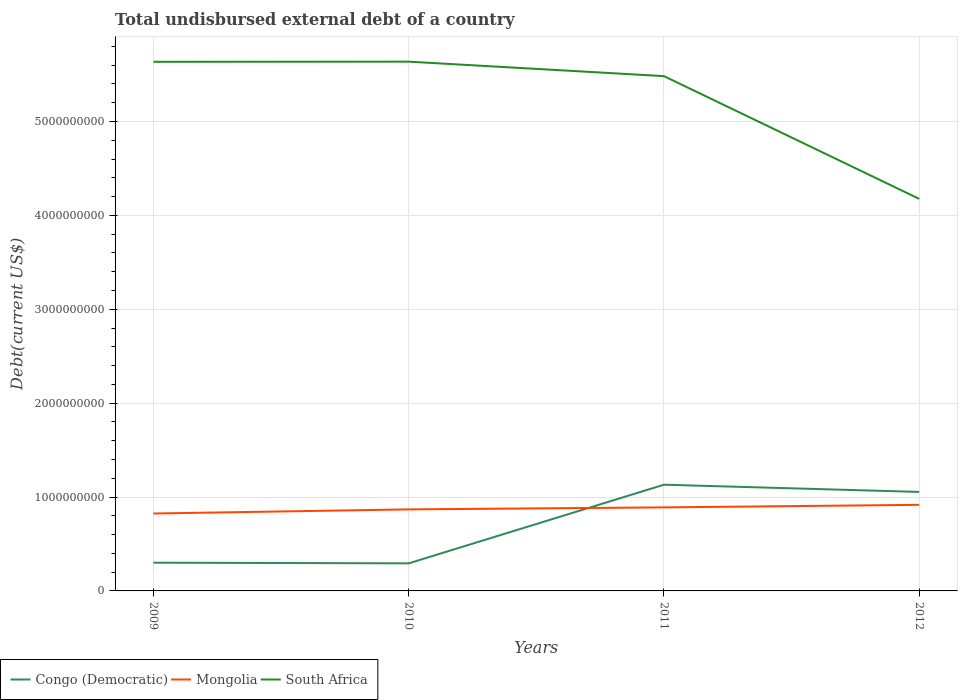How many different coloured lines are there?
Offer a terse response. 3. Across all years, what is the maximum total undisbursed external debt in Mongolia?
Provide a succinct answer. 8.24e+08. In which year was the total undisbursed external debt in South Africa maximum?
Give a very brief answer. 2012. What is the total total undisbursed external debt in South Africa in the graph?
Provide a short and direct response. -1.40e+06. What is the difference between the highest and the second highest total undisbursed external debt in South Africa?
Provide a short and direct response. 1.46e+09. What is the difference between the highest and the lowest total undisbursed external debt in Mongolia?
Give a very brief answer. 2. What is the difference between two consecutive major ticks on the Y-axis?
Make the answer very short. 1.00e+09. Are the values on the major ticks of Y-axis written in scientific E-notation?
Make the answer very short. No. Does the graph contain any zero values?
Your response must be concise. No. Where does the legend appear in the graph?
Ensure brevity in your answer.  Bottom left. How many legend labels are there?
Provide a succinct answer. 3. How are the legend labels stacked?
Offer a terse response. Horizontal. What is the title of the graph?
Offer a very short reply. Total undisbursed external debt of a country. Does "Antigua and Barbuda" appear as one of the legend labels in the graph?
Provide a succinct answer. No. What is the label or title of the Y-axis?
Ensure brevity in your answer.  Debt(current US$). What is the Debt(current US$) of Congo (Democratic) in 2009?
Keep it short and to the point. 3.01e+08. What is the Debt(current US$) in Mongolia in 2009?
Give a very brief answer. 8.24e+08. What is the Debt(current US$) in South Africa in 2009?
Your response must be concise. 5.64e+09. What is the Debt(current US$) of Congo (Democratic) in 2010?
Keep it short and to the point. 2.94e+08. What is the Debt(current US$) of Mongolia in 2010?
Give a very brief answer. 8.69e+08. What is the Debt(current US$) in South Africa in 2010?
Provide a succinct answer. 5.64e+09. What is the Debt(current US$) of Congo (Democratic) in 2011?
Your answer should be compact. 1.13e+09. What is the Debt(current US$) of Mongolia in 2011?
Make the answer very short. 8.90e+08. What is the Debt(current US$) of South Africa in 2011?
Your response must be concise. 5.48e+09. What is the Debt(current US$) in Congo (Democratic) in 2012?
Offer a terse response. 1.05e+09. What is the Debt(current US$) of Mongolia in 2012?
Offer a terse response. 9.17e+08. What is the Debt(current US$) in South Africa in 2012?
Offer a terse response. 4.18e+09. Across all years, what is the maximum Debt(current US$) of Congo (Democratic)?
Keep it short and to the point. 1.13e+09. Across all years, what is the maximum Debt(current US$) in Mongolia?
Make the answer very short. 9.17e+08. Across all years, what is the maximum Debt(current US$) in South Africa?
Provide a succinct answer. 5.64e+09. Across all years, what is the minimum Debt(current US$) in Congo (Democratic)?
Your answer should be compact. 2.94e+08. Across all years, what is the minimum Debt(current US$) of Mongolia?
Your answer should be compact. 8.24e+08. Across all years, what is the minimum Debt(current US$) in South Africa?
Offer a terse response. 4.18e+09. What is the total Debt(current US$) in Congo (Democratic) in the graph?
Provide a succinct answer. 2.78e+09. What is the total Debt(current US$) in Mongolia in the graph?
Your response must be concise. 3.50e+09. What is the total Debt(current US$) of South Africa in the graph?
Offer a very short reply. 2.09e+1. What is the difference between the Debt(current US$) of Congo (Democratic) in 2009 and that in 2010?
Provide a succinct answer. 7.04e+06. What is the difference between the Debt(current US$) of Mongolia in 2009 and that in 2010?
Provide a short and direct response. -4.41e+07. What is the difference between the Debt(current US$) in South Africa in 2009 and that in 2010?
Provide a short and direct response. -1.40e+06. What is the difference between the Debt(current US$) of Congo (Democratic) in 2009 and that in 2011?
Make the answer very short. -8.31e+08. What is the difference between the Debt(current US$) of Mongolia in 2009 and that in 2011?
Make the answer very short. -6.54e+07. What is the difference between the Debt(current US$) in South Africa in 2009 and that in 2011?
Provide a succinct answer. 1.53e+08. What is the difference between the Debt(current US$) in Congo (Democratic) in 2009 and that in 2012?
Offer a terse response. -7.54e+08. What is the difference between the Debt(current US$) in Mongolia in 2009 and that in 2012?
Make the answer very short. -9.25e+07. What is the difference between the Debt(current US$) in South Africa in 2009 and that in 2012?
Your response must be concise. 1.46e+09. What is the difference between the Debt(current US$) of Congo (Democratic) in 2010 and that in 2011?
Offer a very short reply. -8.38e+08. What is the difference between the Debt(current US$) of Mongolia in 2010 and that in 2011?
Give a very brief answer. -2.14e+07. What is the difference between the Debt(current US$) in South Africa in 2010 and that in 2011?
Provide a succinct answer. 1.54e+08. What is the difference between the Debt(current US$) of Congo (Democratic) in 2010 and that in 2012?
Give a very brief answer. -7.61e+08. What is the difference between the Debt(current US$) in Mongolia in 2010 and that in 2012?
Offer a terse response. -4.85e+07. What is the difference between the Debt(current US$) in South Africa in 2010 and that in 2012?
Offer a terse response. 1.46e+09. What is the difference between the Debt(current US$) in Congo (Democratic) in 2011 and that in 2012?
Offer a terse response. 7.69e+07. What is the difference between the Debt(current US$) of Mongolia in 2011 and that in 2012?
Offer a very short reply. -2.71e+07. What is the difference between the Debt(current US$) of South Africa in 2011 and that in 2012?
Your answer should be very brief. 1.31e+09. What is the difference between the Debt(current US$) in Congo (Democratic) in 2009 and the Debt(current US$) in Mongolia in 2010?
Provide a succinct answer. -5.68e+08. What is the difference between the Debt(current US$) of Congo (Democratic) in 2009 and the Debt(current US$) of South Africa in 2010?
Make the answer very short. -5.34e+09. What is the difference between the Debt(current US$) of Mongolia in 2009 and the Debt(current US$) of South Africa in 2010?
Your answer should be very brief. -4.81e+09. What is the difference between the Debt(current US$) in Congo (Democratic) in 2009 and the Debt(current US$) in Mongolia in 2011?
Give a very brief answer. -5.89e+08. What is the difference between the Debt(current US$) of Congo (Democratic) in 2009 and the Debt(current US$) of South Africa in 2011?
Your response must be concise. -5.18e+09. What is the difference between the Debt(current US$) of Mongolia in 2009 and the Debt(current US$) of South Africa in 2011?
Your answer should be very brief. -4.66e+09. What is the difference between the Debt(current US$) of Congo (Democratic) in 2009 and the Debt(current US$) of Mongolia in 2012?
Your response must be concise. -6.16e+08. What is the difference between the Debt(current US$) of Congo (Democratic) in 2009 and the Debt(current US$) of South Africa in 2012?
Your answer should be very brief. -3.88e+09. What is the difference between the Debt(current US$) of Mongolia in 2009 and the Debt(current US$) of South Africa in 2012?
Ensure brevity in your answer.  -3.35e+09. What is the difference between the Debt(current US$) in Congo (Democratic) in 2010 and the Debt(current US$) in Mongolia in 2011?
Your answer should be very brief. -5.96e+08. What is the difference between the Debt(current US$) in Congo (Democratic) in 2010 and the Debt(current US$) in South Africa in 2011?
Provide a succinct answer. -5.19e+09. What is the difference between the Debt(current US$) of Mongolia in 2010 and the Debt(current US$) of South Africa in 2011?
Offer a terse response. -4.62e+09. What is the difference between the Debt(current US$) in Congo (Democratic) in 2010 and the Debt(current US$) in Mongolia in 2012?
Your answer should be compact. -6.23e+08. What is the difference between the Debt(current US$) in Congo (Democratic) in 2010 and the Debt(current US$) in South Africa in 2012?
Keep it short and to the point. -3.88e+09. What is the difference between the Debt(current US$) in Mongolia in 2010 and the Debt(current US$) in South Africa in 2012?
Your answer should be very brief. -3.31e+09. What is the difference between the Debt(current US$) of Congo (Democratic) in 2011 and the Debt(current US$) of Mongolia in 2012?
Give a very brief answer. 2.15e+08. What is the difference between the Debt(current US$) of Congo (Democratic) in 2011 and the Debt(current US$) of South Africa in 2012?
Your answer should be compact. -3.04e+09. What is the difference between the Debt(current US$) of Mongolia in 2011 and the Debt(current US$) of South Africa in 2012?
Ensure brevity in your answer.  -3.29e+09. What is the average Debt(current US$) of Congo (Democratic) per year?
Your response must be concise. 6.95e+08. What is the average Debt(current US$) in Mongolia per year?
Your response must be concise. 8.75e+08. What is the average Debt(current US$) of South Africa per year?
Offer a very short reply. 5.23e+09. In the year 2009, what is the difference between the Debt(current US$) in Congo (Democratic) and Debt(current US$) in Mongolia?
Keep it short and to the point. -5.24e+08. In the year 2009, what is the difference between the Debt(current US$) of Congo (Democratic) and Debt(current US$) of South Africa?
Keep it short and to the point. -5.34e+09. In the year 2009, what is the difference between the Debt(current US$) of Mongolia and Debt(current US$) of South Africa?
Provide a succinct answer. -4.81e+09. In the year 2010, what is the difference between the Debt(current US$) of Congo (Democratic) and Debt(current US$) of Mongolia?
Your answer should be very brief. -5.75e+08. In the year 2010, what is the difference between the Debt(current US$) of Congo (Democratic) and Debt(current US$) of South Africa?
Provide a succinct answer. -5.34e+09. In the year 2010, what is the difference between the Debt(current US$) in Mongolia and Debt(current US$) in South Africa?
Provide a short and direct response. -4.77e+09. In the year 2011, what is the difference between the Debt(current US$) in Congo (Democratic) and Debt(current US$) in Mongolia?
Provide a short and direct response. 2.42e+08. In the year 2011, what is the difference between the Debt(current US$) in Congo (Democratic) and Debt(current US$) in South Africa?
Your answer should be compact. -4.35e+09. In the year 2011, what is the difference between the Debt(current US$) in Mongolia and Debt(current US$) in South Africa?
Your response must be concise. -4.59e+09. In the year 2012, what is the difference between the Debt(current US$) in Congo (Democratic) and Debt(current US$) in Mongolia?
Offer a very short reply. 1.38e+08. In the year 2012, what is the difference between the Debt(current US$) in Congo (Democratic) and Debt(current US$) in South Africa?
Offer a very short reply. -3.12e+09. In the year 2012, what is the difference between the Debt(current US$) of Mongolia and Debt(current US$) of South Africa?
Your answer should be very brief. -3.26e+09. What is the ratio of the Debt(current US$) of Mongolia in 2009 to that in 2010?
Ensure brevity in your answer.  0.95. What is the ratio of the Debt(current US$) in Congo (Democratic) in 2009 to that in 2011?
Keep it short and to the point. 0.27. What is the ratio of the Debt(current US$) of Mongolia in 2009 to that in 2011?
Offer a very short reply. 0.93. What is the ratio of the Debt(current US$) in South Africa in 2009 to that in 2011?
Provide a short and direct response. 1.03. What is the ratio of the Debt(current US$) of Congo (Democratic) in 2009 to that in 2012?
Offer a very short reply. 0.29. What is the ratio of the Debt(current US$) of Mongolia in 2009 to that in 2012?
Your answer should be compact. 0.9. What is the ratio of the Debt(current US$) in South Africa in 2009 to that in 2012?
Offer a very short reply. 1.35. What is the ratio of the Debt(current US$) in Congo (Democratic) in 2010 to that in 2011?
Make the answer very short. 0.26. What is the ratio of the Debt(current US$) of South Africa in 2010 to that in 2011?
Your answer should be compact. 1.03. What is the ratio of the Debt(current US$) of Congo (Democratic) in 2010 to that in 2012?
Your response must be concise. 0.28. What is the ratio of the Debt(current US$) of Mongolia in 2010 to that in 2012?
Make the answer very short. 0.95. What is the ratio of the Debt(current US$) in South Africa in 2010 to that in 2012?
Provide a short and direct response. 1.35. What is the ratio of the Debt(current US$) of Congo (Democratic) in 2011 to that in 2012?
Give a very brief answer. 1.07. What is the ratio of the Debt(current US$) in Mongolia in 2011 to that in 2012?
Your response must be concise. 0.97. What is the ratio of the Debt(current US$) in South Africa in 2011 to that in 2012?
Keep it short and to the point. 1.31. What is the difference between the highest and the second highest Debt(current US$) in Congo (Democratic)?
Provide a succinct answer. 7.69e+07. What is the difference between the highest and the second highest Debt(current US$) in Mongolia?
Provide a succinct answer. 2.71e+07. What is the difference between the highest and the second highest Debt(current US$) of South Africa?
Your response must be concise. 1.40e+06. What is the difference between the highest and the lowest Debt(current US$) in Congo (Democratic)?
Your response must be concise. 8.38e+08. What is the difference between the highest and the lowest Debt(current US$) in Mongolia?
Provide a short and direct response. 9.25e+07. What is the difference between the highest and the lowest Debt(current US$) in South Africa?
Ensure brevity in your answer.  1.46e+09. 